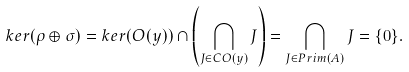Convert formula to latex. <formula><loc_0><loc_0><loc_500><loc_500>k e r ( \rho \oplus \sigma ) = k e r ( O ( y ) ) \cap \left ( \bigcap _ { J \in C O ( y ) } J \right ) = \bigcap _ { J \in P r i m ( A ) } J = \{ 0 \} .</formula> 